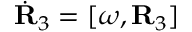Convert formula to latex. <formula><loc_0><loc_0><loc_500><loc_500>\dot { R } _ { 3 } = [ { \boldsymbol \omega } , { R } _ { 3 } ]</formula> 